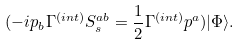Convert formula to latex. <formula><loc_0><loc_0><loc_500><loc_500>( - i p _ { b } \Gamma ^ { ( i n t ) } S _ { s } ^ { a b } = \frac { 1 } { 2 } \Gamma ^ { ( i n t ) } p ^ { a } ) | \Phi \rangle .</formula> 